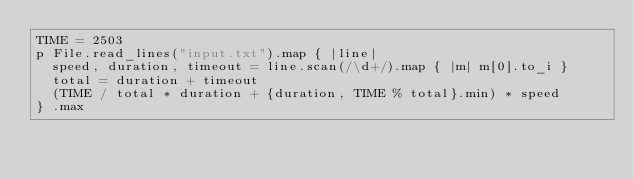<code> <loc_0><loc_0><loc_500><loc_500><_Crystal_>TIME = 2503
p File.read_lines("input.txt").map { |line|
  speed, duration, timeout = line.scan(/\d+/).map { |m| m[0].to_i }
  total = duration + timeout
  (TIME / total * duration + {duration, TIME % total}.min) * speed
} .max
</code> 